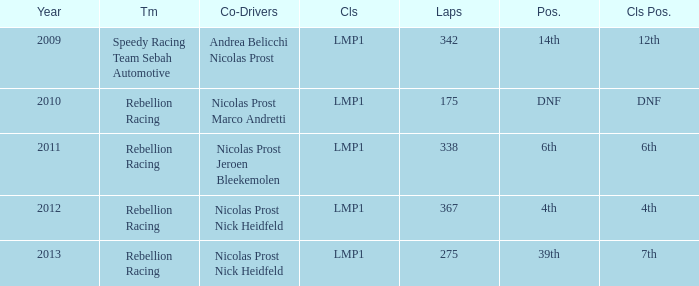What was the class position of the team that was in the 4th position? 4th. 